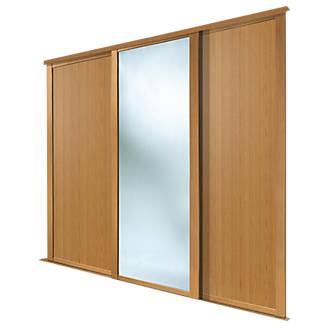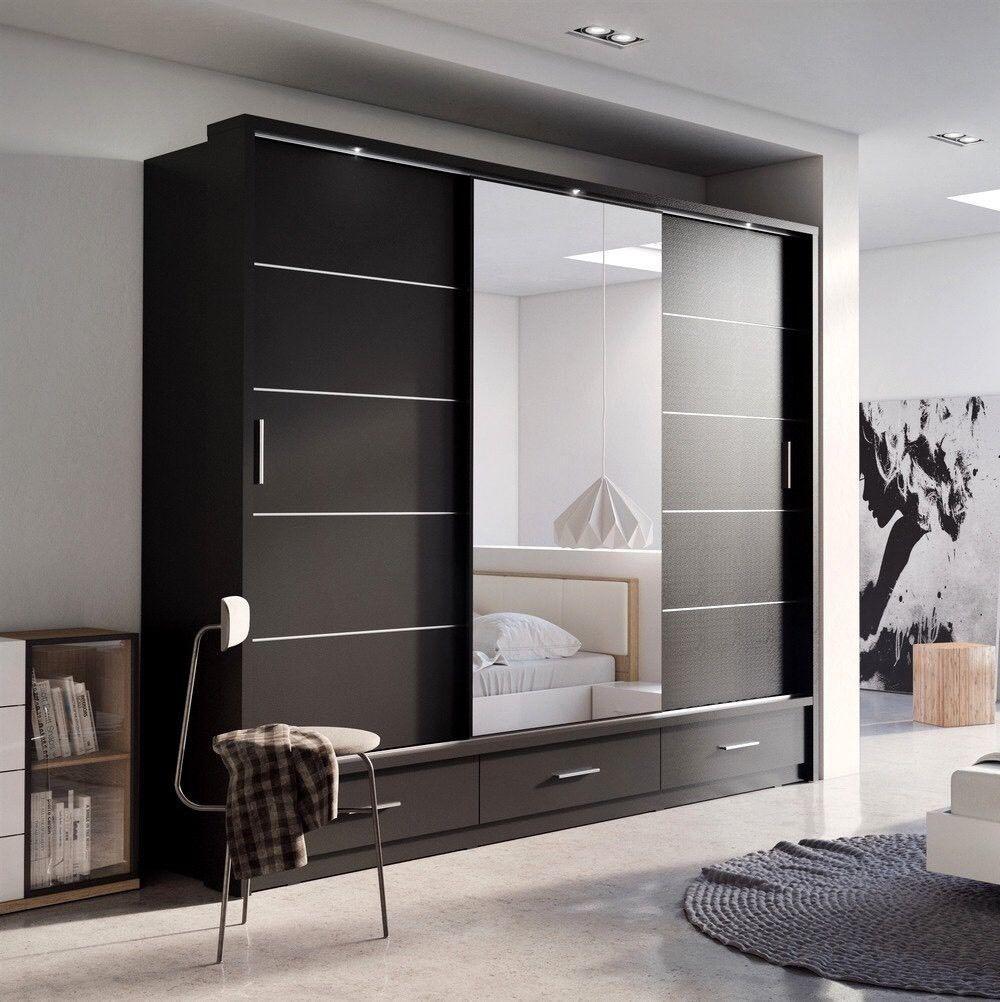The first image is the image on the left, the second image is the image on the right. Examine the images to the left and right. Is the description "there is a closet with a curtained window on the wall to the right" accurate? Answer yes or no. No. 